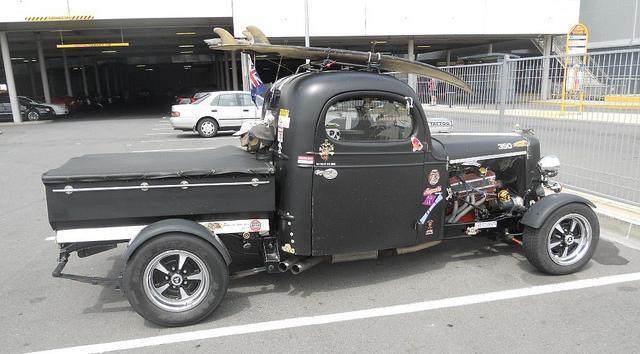What hobby does the car owner enjoy?
Choose the right answer and clarify with the format: 'Answer: answer
Rationale: rationale.'
Options: Skating, painting, surfing, biking. Answer: surfing.
Rationale: A surfboard is tied on top of the roof. people tie surfboards to the roof when they want to go surfing. 